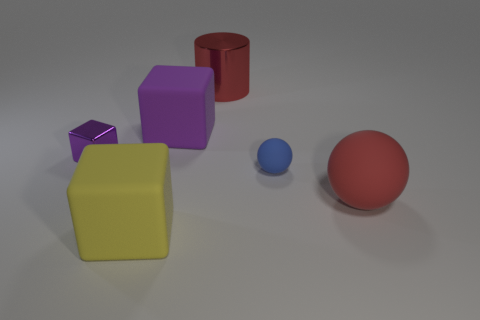Subtract all rubber cubes. How many cubes are left? 1 Add 4 purple rubber spheres. How many objects exist? 10 Subtract all blue spheres. How many spheres are left? 1 Subtract all cylinders. How many objects are left? 5 Subtract all gray balls. How many purple blocks are left? 2 Subtract all green shiny cylinders. Subtract all small matte objects. How many objects are left? 5 Add 4 red rubber balls. How many red rubber balls are left? 5 Add 4 red matte balls. How many red matte balls exist? 5 Subtract 1 blue spheres. How many objects are left? 5 Subtract all gray cubes. Subtract all green spheres. How many cubes are left? 3 